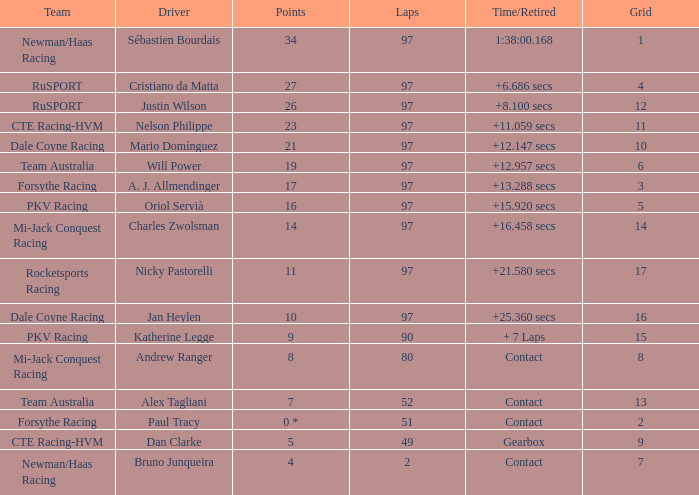What team does jan heylen race for? Dale Coyne Racing. 